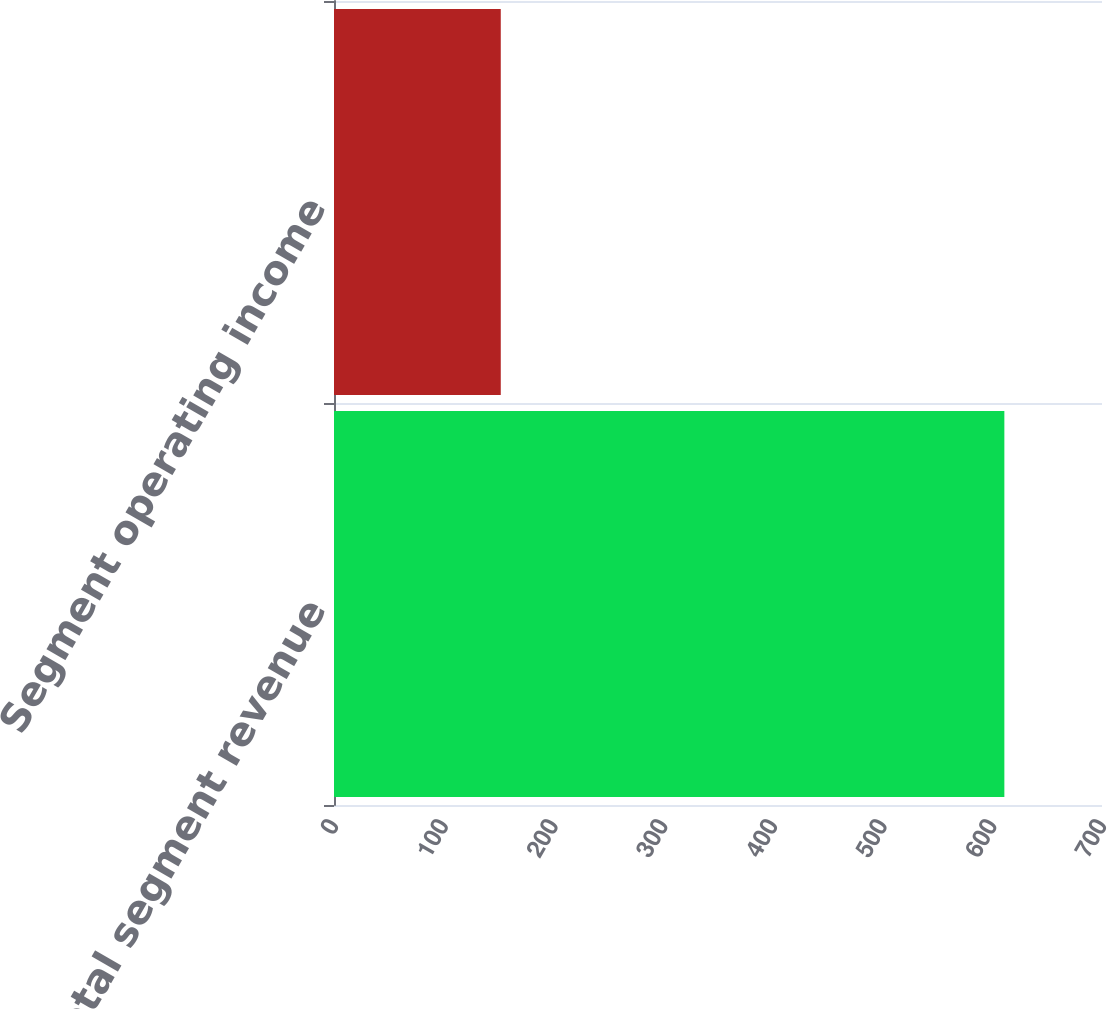<chart> <loc_0><loc_0><loc_500><loc_500><bar_chart><fcel>Total segment revenue<fcel>Segment operating income<nl><fcel>611<fcel>152<nl></chart> 